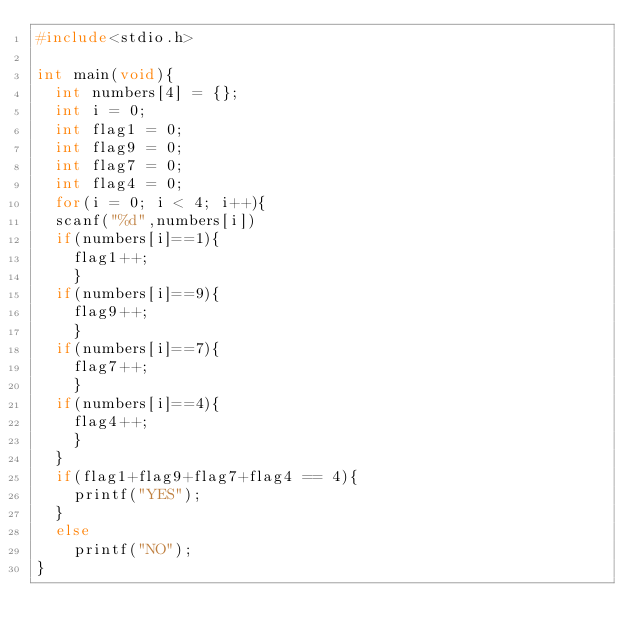Convert code to text. <code><loc_0><loc_0><loc_500><loc_500><_C_>#include<stdio.h>

int main(void){
  int numbers[4] = {}; 
  int i = 0;
  int flag1 = 0;
  int flag9 = 0;
  int flag7 = 0;
  int flag4 = 0;
  for(i = 0; i < 4; i++){
  scanf("%d",numbers[i])
  if(numbers[i]==1){
    flag1++;
  	}
  if(numbers[i]==9){
    flag9++;
  	}
  if(numbers[i]==7){
    flag7++;
  	}
  if(numbers[i]==4){
    flag4++;
  	}  
  }
  if(flag1+flag9+flag7+flag4 == 4){
    printf("YES");
  }
  else
    printf("NO");
}</code> 